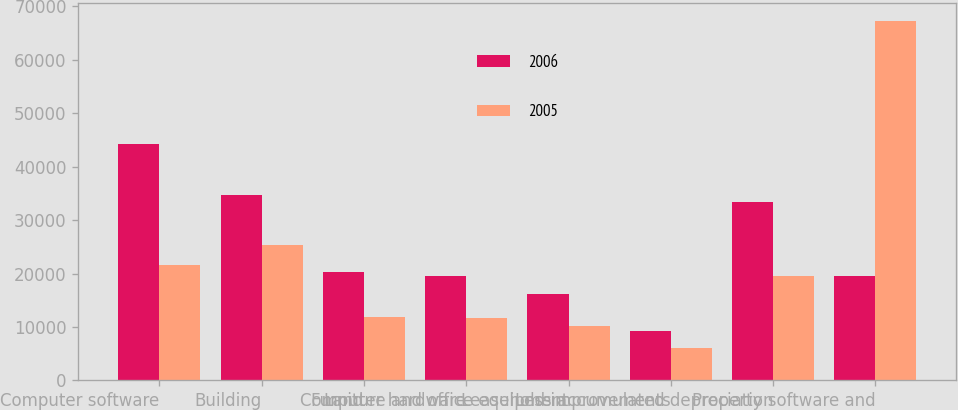Convert chart to OTSL. <chart><loc_0><loc_0><loc_500><loc_500><stacked_bar_chart><ecel><fcel>Computer software<fcel>Building<fcel>Land<fcel>Computer hardware<fcel>Furniture and office equipment<fcel>Leasehold improvements<fcel>Less accumulated depreciation<fcel>Property software and<nl><fcel>2006<fcel>44292<fcel>34671<fcel>20216<fcel>19580<fcel>16114<fcel>9226<fcel>33411<fcel>19580<nl><fcel>2005<fcel>21510<fcel>25376<fcel>11815<fcel>11717<fcel>10163<fcel>6125<fcel>19507<fcel>67199<nl></chart> 